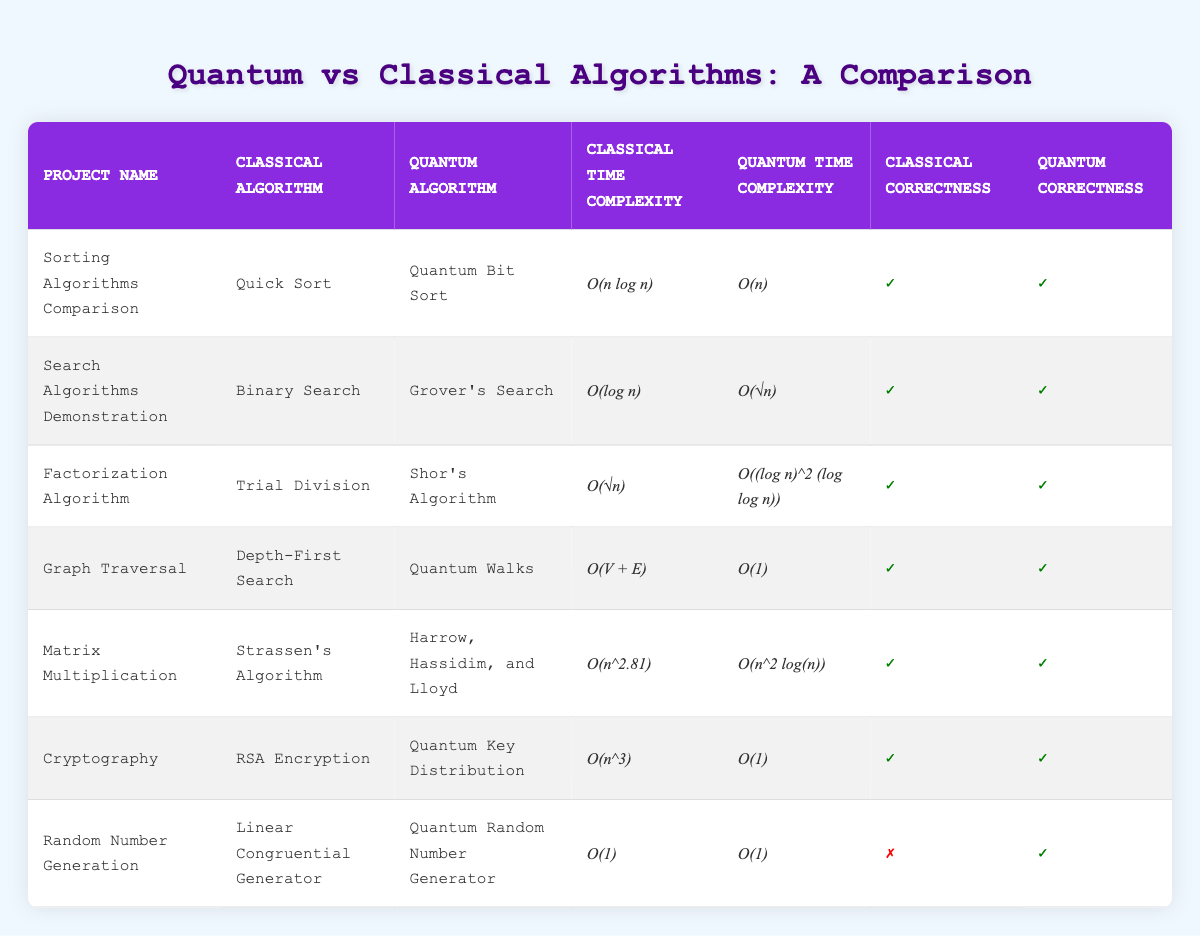What is the time complexity of the classic algorithm used in "Sorting Algorithms Comparison"? From the table, the classical algorithm used in "Sorting Algorithms Comparison" is Quick Sort, and its time complexity is listed as O(n log n).
Answer: O(n log n) Which quantum algorithm has the best time complexity according to the table? In the table, the time complexities of the quantum algorithms are compared. Quantum Bit Sort (O(n)), Grover's Search (O(√n)), Shor's Algorithm (O((log n)^2 (log log n))), Quantum Walks (O(1)), Harrow, Hassidim, and Lloyd (O(n^2 log(n))), and Quantum Key Distribution (O(1)). The best (smallest) time complexity is O(1) which is shared by Quantum Walks and Quantum Key Distribution.
Answer: O(1) Are all the quantum algorithms shown in the table correct? Looking at the correctness column for quantum algorithms, every entry shows a check mark (✓) indicating that their correctness is confirmed.
Answer: Yes What is the time complexity difference between classical and quantum algorithms for "Graph Traversal"? For "Graph Traversal", the classical algorithm is Depth-First Search with a complexity of O(V + E), and the quantum algorithm is Quantum Walks with a complexity of O(1). The difference indicates that the quantum algorithm is significantly faster since O(1) is a lower complexity than O(V + E), where V and E are the number of vertices and edges respectively.
Answer: O(V + E) vs O(1) How many projects utilize algorithms with a correctness value of true for both classical and quantum algorithms? By scanning through the correctness columns, it is clear that six projects have a correctness value of true (✓) for both algorithms: Sorting Algorithms Comparison, Search Algorithms Demonstration, Factorization Algorithm, Graph Traversal, Matrix Multiplication, and Cryptography. Only the Random Number Generation project shows a false (✗) for classical correctness. Thus, there are 6 projects with true values for both.
Answer: 6 Which project demonstrates an algorithm that is correct for the quantum version but not for the classical version? In the table, only the Random Number Generation project has a correctness value of false for the classical algorithm (Linear Congruential Generator) and true for the quantum algorithm (Quantum Random Number Generator). Therefore, this project uniquely demonstrates this scenario.
Answer: Random Number Generation What is the average time complexity of the classical algorithms used in the provided projects? To compute the average, we review each classical time complexity value: O(n log n), O(log n), O(√n), O(V + E), O(n^2.81), O(n^3), and O(1). While we cannot sum these complexities directly, we can conclude that they showcase varying complexities, demonstrating that classical algorithms are generally polynomially based whereas one is logarithmic and another is constant. Thus, while we can't quantify a numerical average directly, we can see a trend of increasing complexity.
Answer: Not computable directly Are there more classical algorithms with polynomial time complexities than quantum algorithms in the projects listed? By reviewing the time complexity values, classical algorithms like O(n log n), O(log n), O(√n), O(V + E), O(n^2.81), and O(n^3) show polynomial complexities while the quantum algorithms generally have logarithmic, constant, or sublogarithmic complexities. We find that there are 6 classical algorithms with polynomial time complexities, while quantum algorithms show less. Hence, yes, there are indeed more classical polynomial complexities.
Answer: Yes 